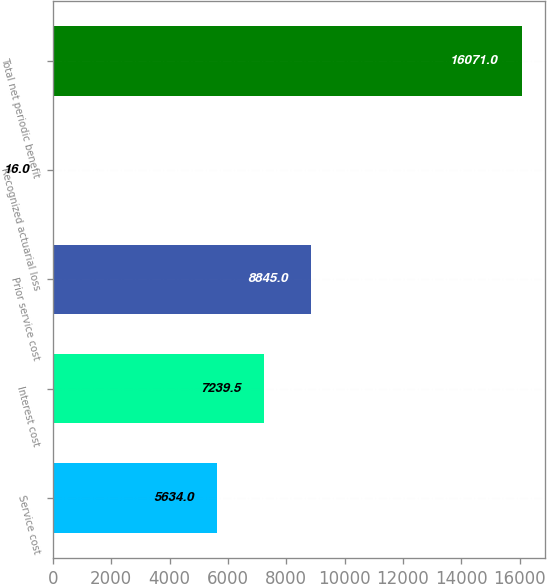Convert chart. <chart><loc_0><loc_0><loc_500><loc_500><bar_chart><fcel>Service cost<fcel>Interest cost<fcel>Prior service cost<fcel>Recognized actuarial loss<fcel>Total net periodic benefit<nl><fcel>5634<fcel>7239.5<fcel>8845<fcel>16<fcel>16071<nl></chart> 